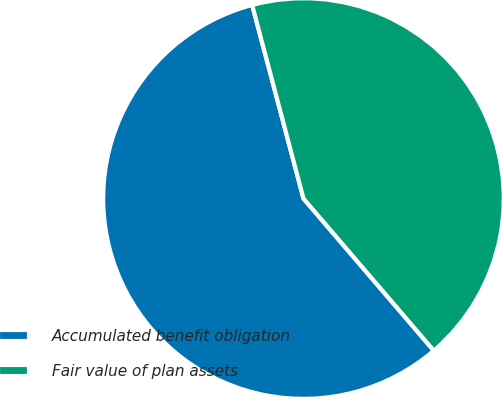Convert chart. <chart><loc_0><loc_0><loc_500><loc_500><pie_chart><fcel>Accumulated benefit obligation<fcel>Fair value of plan assets<nl><fcel>57.15%<fcel>42.85%<nl></chart> 